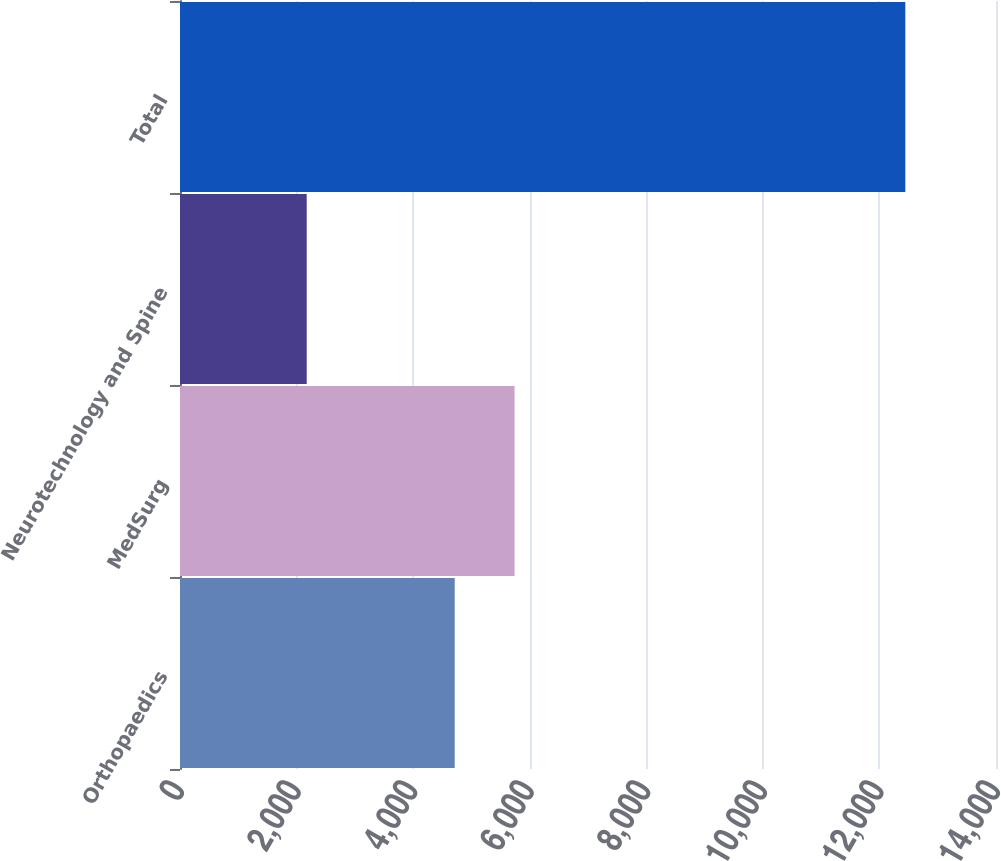Convert chart. <chart><loc_0><loc_0><loc_500><loc_500><bar_chart><fcel>Orthopaedics<fcel>MedSurg<fcel>Neurotechnology and Spine<fcel>Total<nl><fcel>4713<fcel>5740<fcel>2174<fcel>12444<nl></chart> 